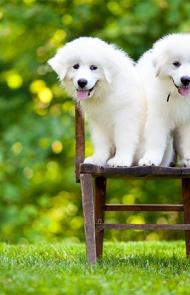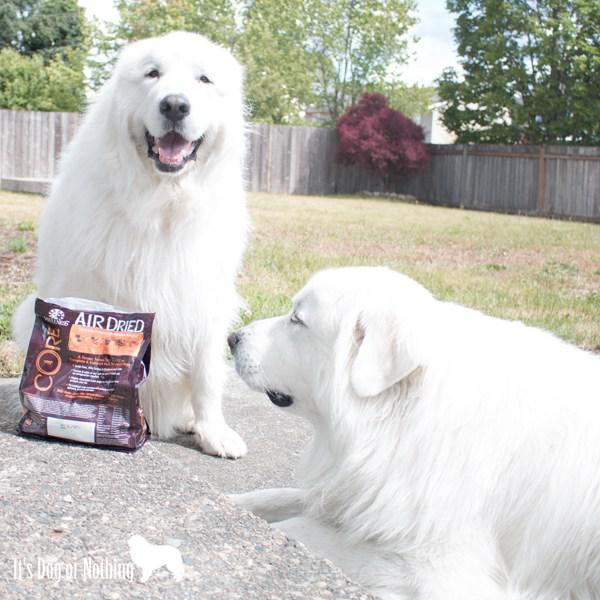The first image is the image on the left, the second image is the image on the right. Assess this claim about the two images: "If one dog is lying down, there are no sitting dogs near them.". Correct or not? Answer yes or no. No. 